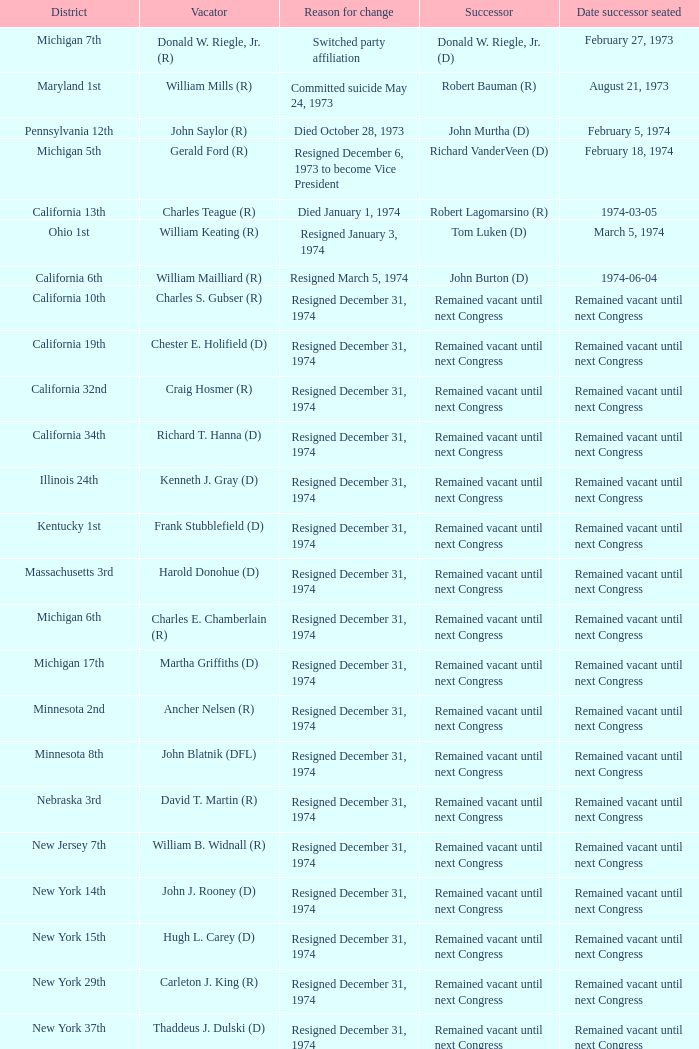Give me the full table as a dictionary. {'header': ['District', 'Vacator', 'Reason for change', 'Successor', 'Date successor seated'], 'rows': [['Michigan 7th', 'Donald W. Riegle, Jr. (R)', 'Switched party affiliation', 'Donald W. Riegle, Jr. (D)', 'February 27, 1973'], ['Maryland 1st', 'William Mills (R)', 'Committed suicide May 24, 1973', 'Robert Bauman (R)', 'August 21, 1973'], ['Pennsylvania 12th', 'John Saylor (R)', 'Died October 28, 1973', 'John Murtha (D)', 'February 5, 1974'], ['Michigan 5th', 'Gerald Ford (R)', 'Resigned December 6, 1973 to become Vice President', 'Richard VanderVeen (D)', 'February 18, 1974'], ['California 13th', 'Charles Teague (R)', 'Died January 1, 1974', 'Robert Lagomarsino (R)', '1974-03-05'], ['Ohio 1st', 'William Keating (R)', 'Resigned January 3, 1974', 'Tom Luken (D)', 'March 5, 1974'], ['California 6th', 'William Mailliard (R)', 'Resigned March 5, 1974', 'John Burton (D)', '1974-06-04'], ['California 10th', 'Charles S. Gubser (R)', 'Resigned December 31, 1974', 'Remained vacant until next Congress', 'Remained vacant until next Congress'], ['California 19th', 'Chester E. Holifield (D)', 'Resigned December 31, 1974', 'Remained vacant until next Congress', 'Remained vacant until next Congress'], ['California 32nd', 'Craig Hosmer (R)', 'Resigned December 31, 1974', 'Remained vacant until next Congress', 'Remained vacant until next Congress'], ['California 34th', 'Richard T. Hanna (D)', 'Resigned December 31, 1974', 'Remained vacant until next Congress', 'Remained vacant until next Congress'], ['Illinois 24th', 'Kenneth J. Gray (D)', 'Resigned December 31, 1974', 'Remained vacant until next Congress', 'Remained vacant until next Congress'], ['Kentucky 1st', 'Frank Stubblefield (D)', 'Resigned December 31, 1974', 'Remained vacant until next Congress', 'Remained vacant until next Congress'], ['Massachusetts 3rd', 'Harold Donohue (D)', 'Resigned December 31, 1974', 'Remained vacant until next Congress', 'Remained vacant until next Congress'], ['Michigan 6th', 'Charles E. Chamberlain (R)', 'Resigned December 31, 1974', 'Remained vacant until next Congress', 'Remained vacant until next Congress'], ['Michigan 17th', 'Martha Griffiths (D)', 'Resigned December 31, 1974', 'Remained vacant until next Congress', 'Remained vacant until next Congress'], ['Minnesota 2nd', 'Ancher Nelsen (R)', 'Resigned December 31, 1974', 'Remained vacant until next Congress', 'Remained vacant until next Congress'], ['Minnesota 8th', 'John Blatnik (DFL)', 'Resigned December 31, 1974', 'Remained vacant until next Congress', 'Remained vacant until next Congress'], ['Nebraska 3rd', 'David T. Martin (R)', 'Resigned December 31, 1974', 'Remained vacant until next Congress', 'Remained vacant until next Congress'], ['New Jersey 7th', 'William B. Widnall (R)', 'Resigned December 31, 1974', 'Remained vacant until next Congress', 'Remained vacant until next Congress'], ['New York 14th', 'John J. Rooney (D)', 'Resigned December 31, 1974', 'Remained vacant until next Congress', 'Remained vacant until next Congress'], ['New York 15th', 'Hugh L. Carey (D)', 'Resigned December 31, 1974', 'Remained vacant until next Congress', 'Remained vacant until next Congress'], ['New York 29th', 'Carleton J. King (R)', 'Resigned December 31, 1974', 'Remained vacant until next Congress', 'Remained vacant until next Congress'], ['New York 37th', 'Thaddeus J. Dulski (D)', 'Resigned December 31, 1974', 'Remained vacant until next Congress', 'Remained vacant until next Congress'], ['Ohio 23rd', 'William Minshall (R)', 'Resigned December 31, 1974', 'Remained vacant until next Congress', 'Remained vacant until next Congress'], ['Oregon 3rd', 'Edith S. Green (D)', 'Resigned December 31, 1974', 'Remained vacant until next Congress', 'Remained vacant until next Congress'], ['Pennsylvania 25th', 'Frank M. Clark (D)', 'Resigned December 31, 1974', 'Remained vacant until next Congress', 'Remained vacant until next Congress'], ['South Carolina 3rd', 'W.J. Bryan Dorn (D)', 'Resigned December 31, 1974', 'Remained vacant until next Congress', 'Remained vacant until next Congress'], ['South Carolina 5th', 'Thomas S. Gettys (D)', 'Resigned December 31, 1974', 'Remained vacant until next Congress', 'Remained vacant until next Congress'], ['Texas 21st', 'O. C. Fisher (D)', 'Resigned December 31, 1974', 'Remained vacant until next Congress', 'Remained vacant until next Congress'], ['Washington 3rd', 'Julia B. Hansen (D)', 'Resigned December 31, 1974', 'Remained vacant until next Congress', 'Remained vacant until next Congress'], ['Wisconsin 3rd', 'Vernon W. Thomson (R)', 'Resigned December 31, 1974', 'Remained vacant until next Congress', 'Remained vacant until next Congress']]} What was the district when the reason for change was died January 1, 1974? California 13th. 